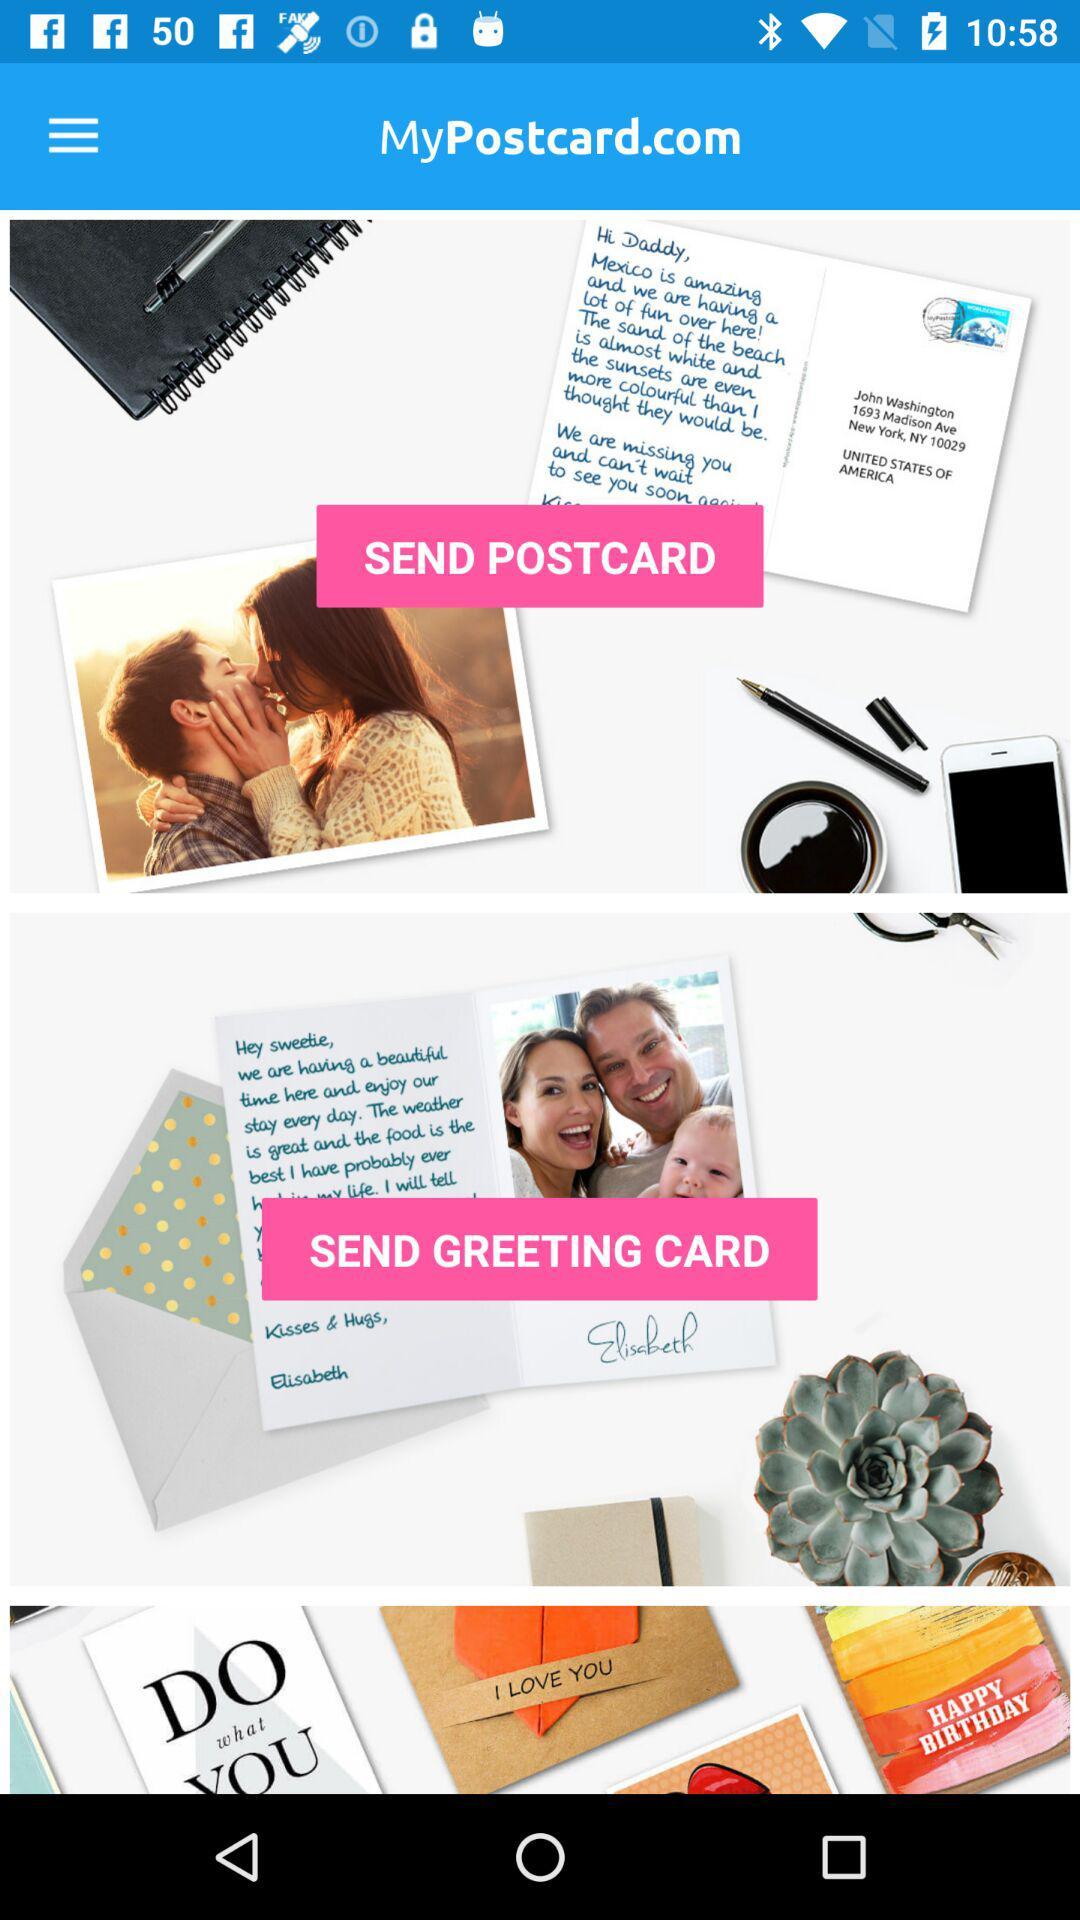What is the name of the application? The name of the application is "MyPostcard.com". 